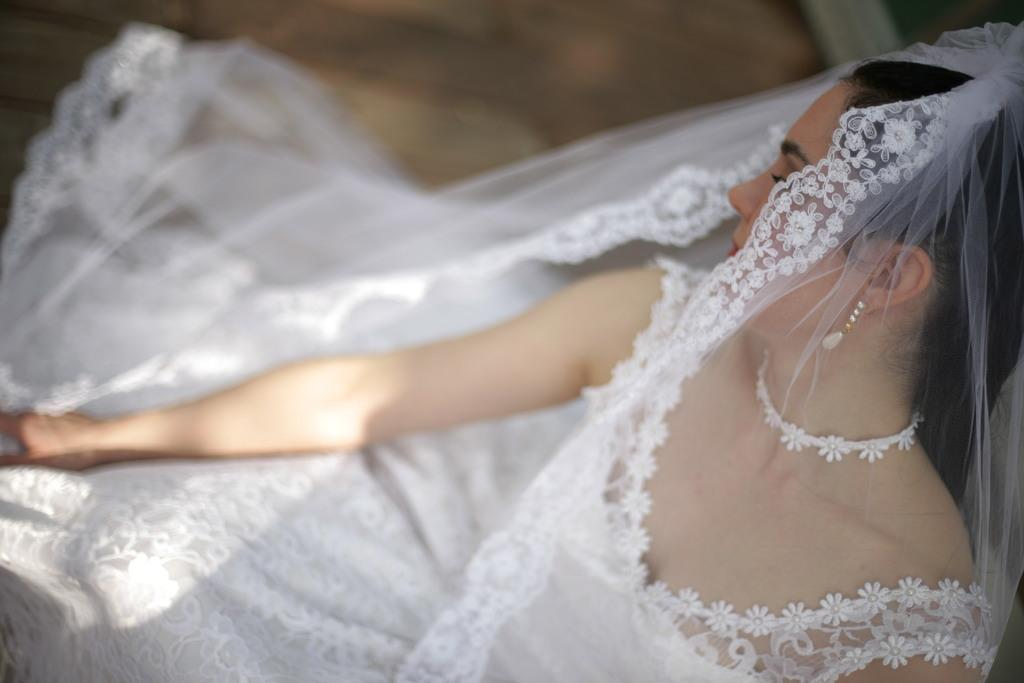Who is present in the image? There is a woman in the image. What is the woman wearing? The woman is wearing a white dress. What type of wood is used to make the soda can in the image? There is no soda can or wood present in the image. 